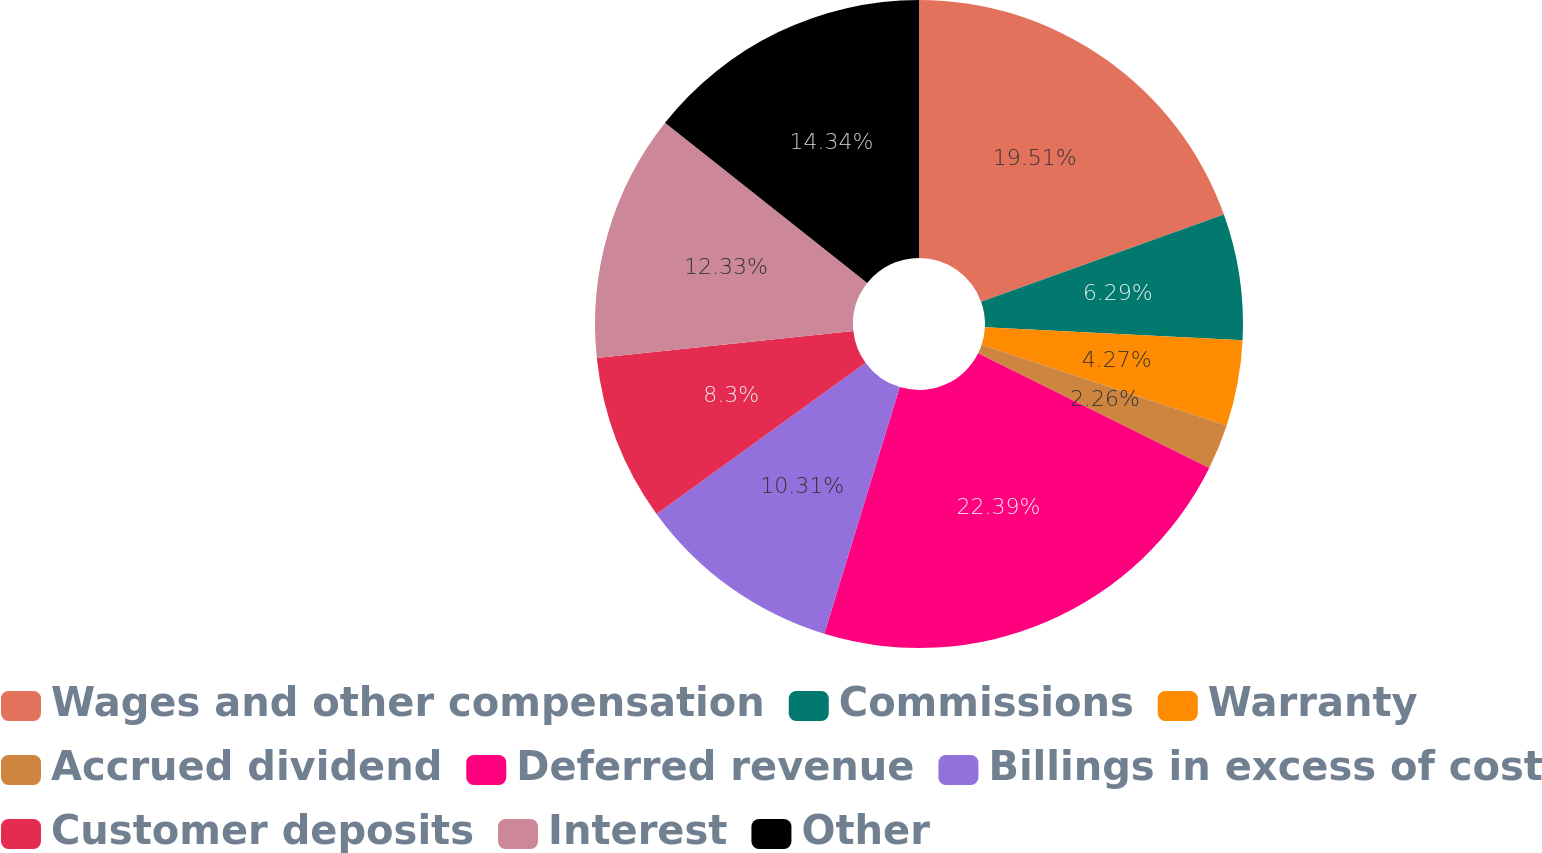Convert chart. <chart><loc_0><loc_0><loc_500><loc_500><pie_chart><fcel>Wages and other compensation<fcel>Commissions<fcel>Warranty<fcel>Accrued dividend<fcel>Deferred revenue<fcel>Billings in excess of cost<fcel>Customer deposits<fcel>Interest<fcel>Other<nl><fcel>19.51%<fcel>6.29%<fcel>4.27%<fcel>2.26%<fcel>22.39%<fcel>10.31%<fcel>8.3%<fcel>12.33%<fcel>14.34%<nl></chart> 